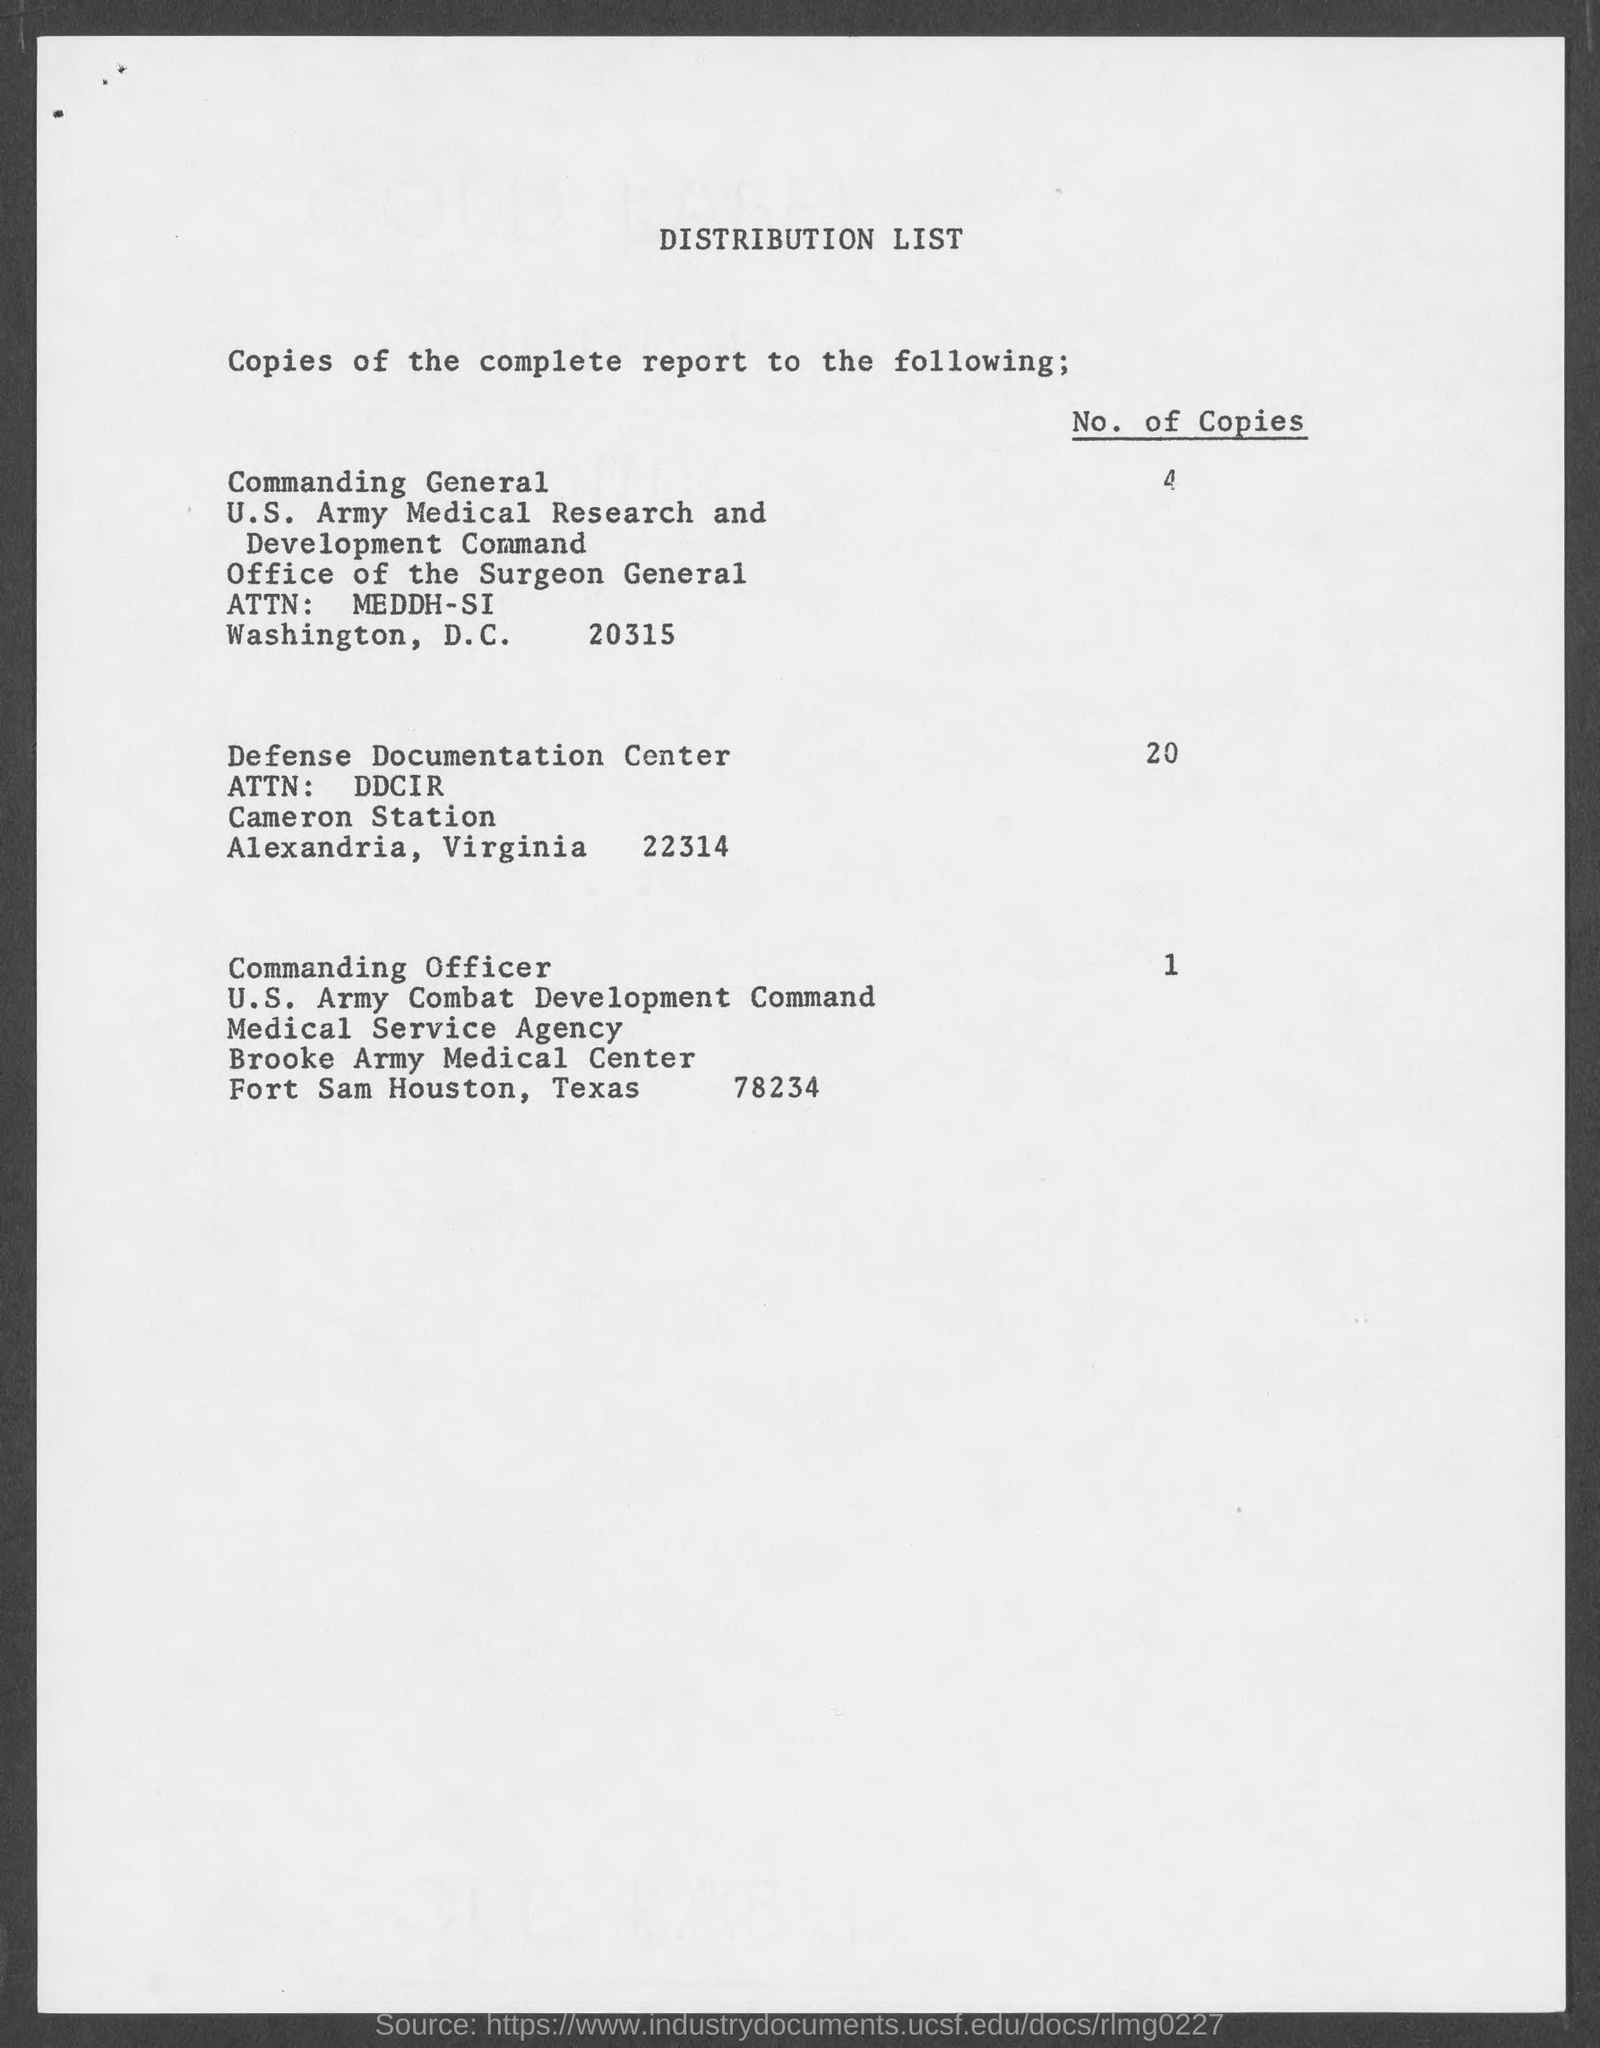What details are provided for the Commanding General's address? The details provided for the Commanding General's address include that it is in Washington, D.C., with the zip code 20315, and it is part of the U.S. Army Medical Research and Development Command, under the office of the Surgeon General with attention to MEDDH-SI. 